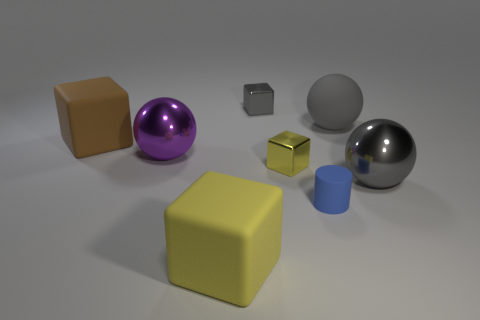What is the material of the tiny cube that is the same color as the large matte ball?
Make the answer very short. Metal. What number of rubber cylinders have the same color as the tiny matte thing?
Your response must be concise. 0. Is the size of the cylinder the same as the gray cube?
Your response must be concise. Yes. There is a thing that is on the left side of the ball left of the yellow rubber block; what size is it?
Make the answer very short. Large. Does the small rubber object have the same color as the big ball that is behind the purple shiny thing?
Give a very brief answer. No. Is there a brown block of the same size as the yellow rubber block?
Your answer should be very brief. Yes. How big is the sphere behind the large purple shiny object?
Provide a succinct answer. Large. Are there any yellow matte things that are to the right of the small blue rubber object that is to the right of the large purple metallic thing?
Provide a short and direct response. No. What number of other objects are there of the same shape as the big yellow object?
Ensure brevity in your answer.  3. Does the tiny gray metal thing have the same shape as the yellow matte thing?
Offer a very short reply. Yes. 